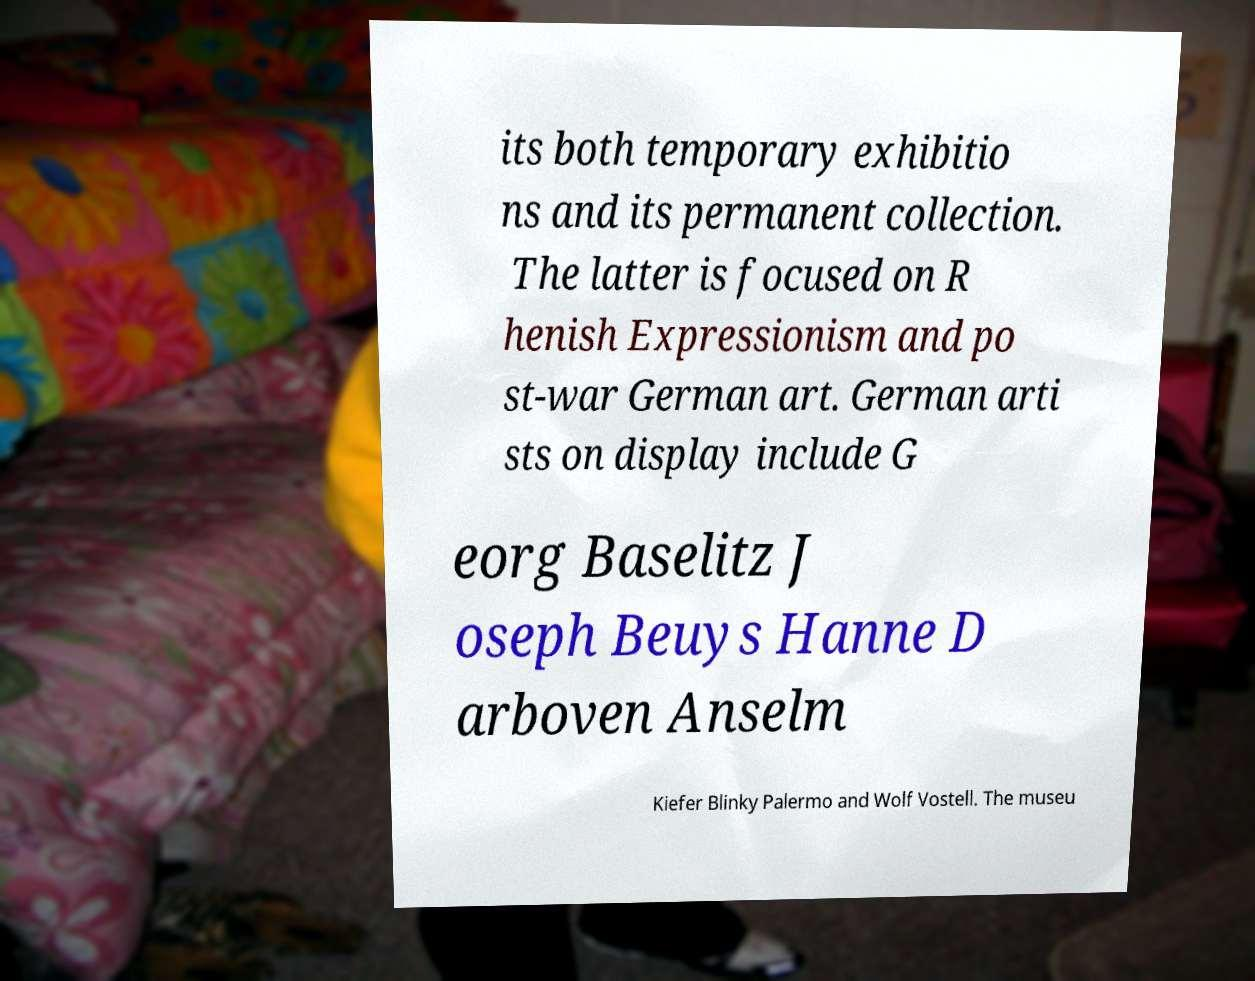What messages or text are displayed in this image? I need them in a readable, typed format. its both temporary exhibitio ns and its permanent collection. The latter is focused on R henish Expressionism and po st-war German art. German arti sts on display include G eorg Baselitz J oseph Beuys Hanne D arboven Anselm Kiefer Blinky Palermo and Wolf Vostell. The museu 